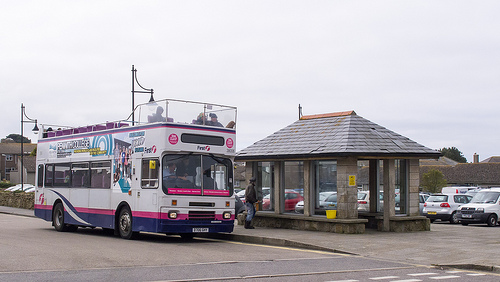What is carrying the people? The bus is carrying the people. 